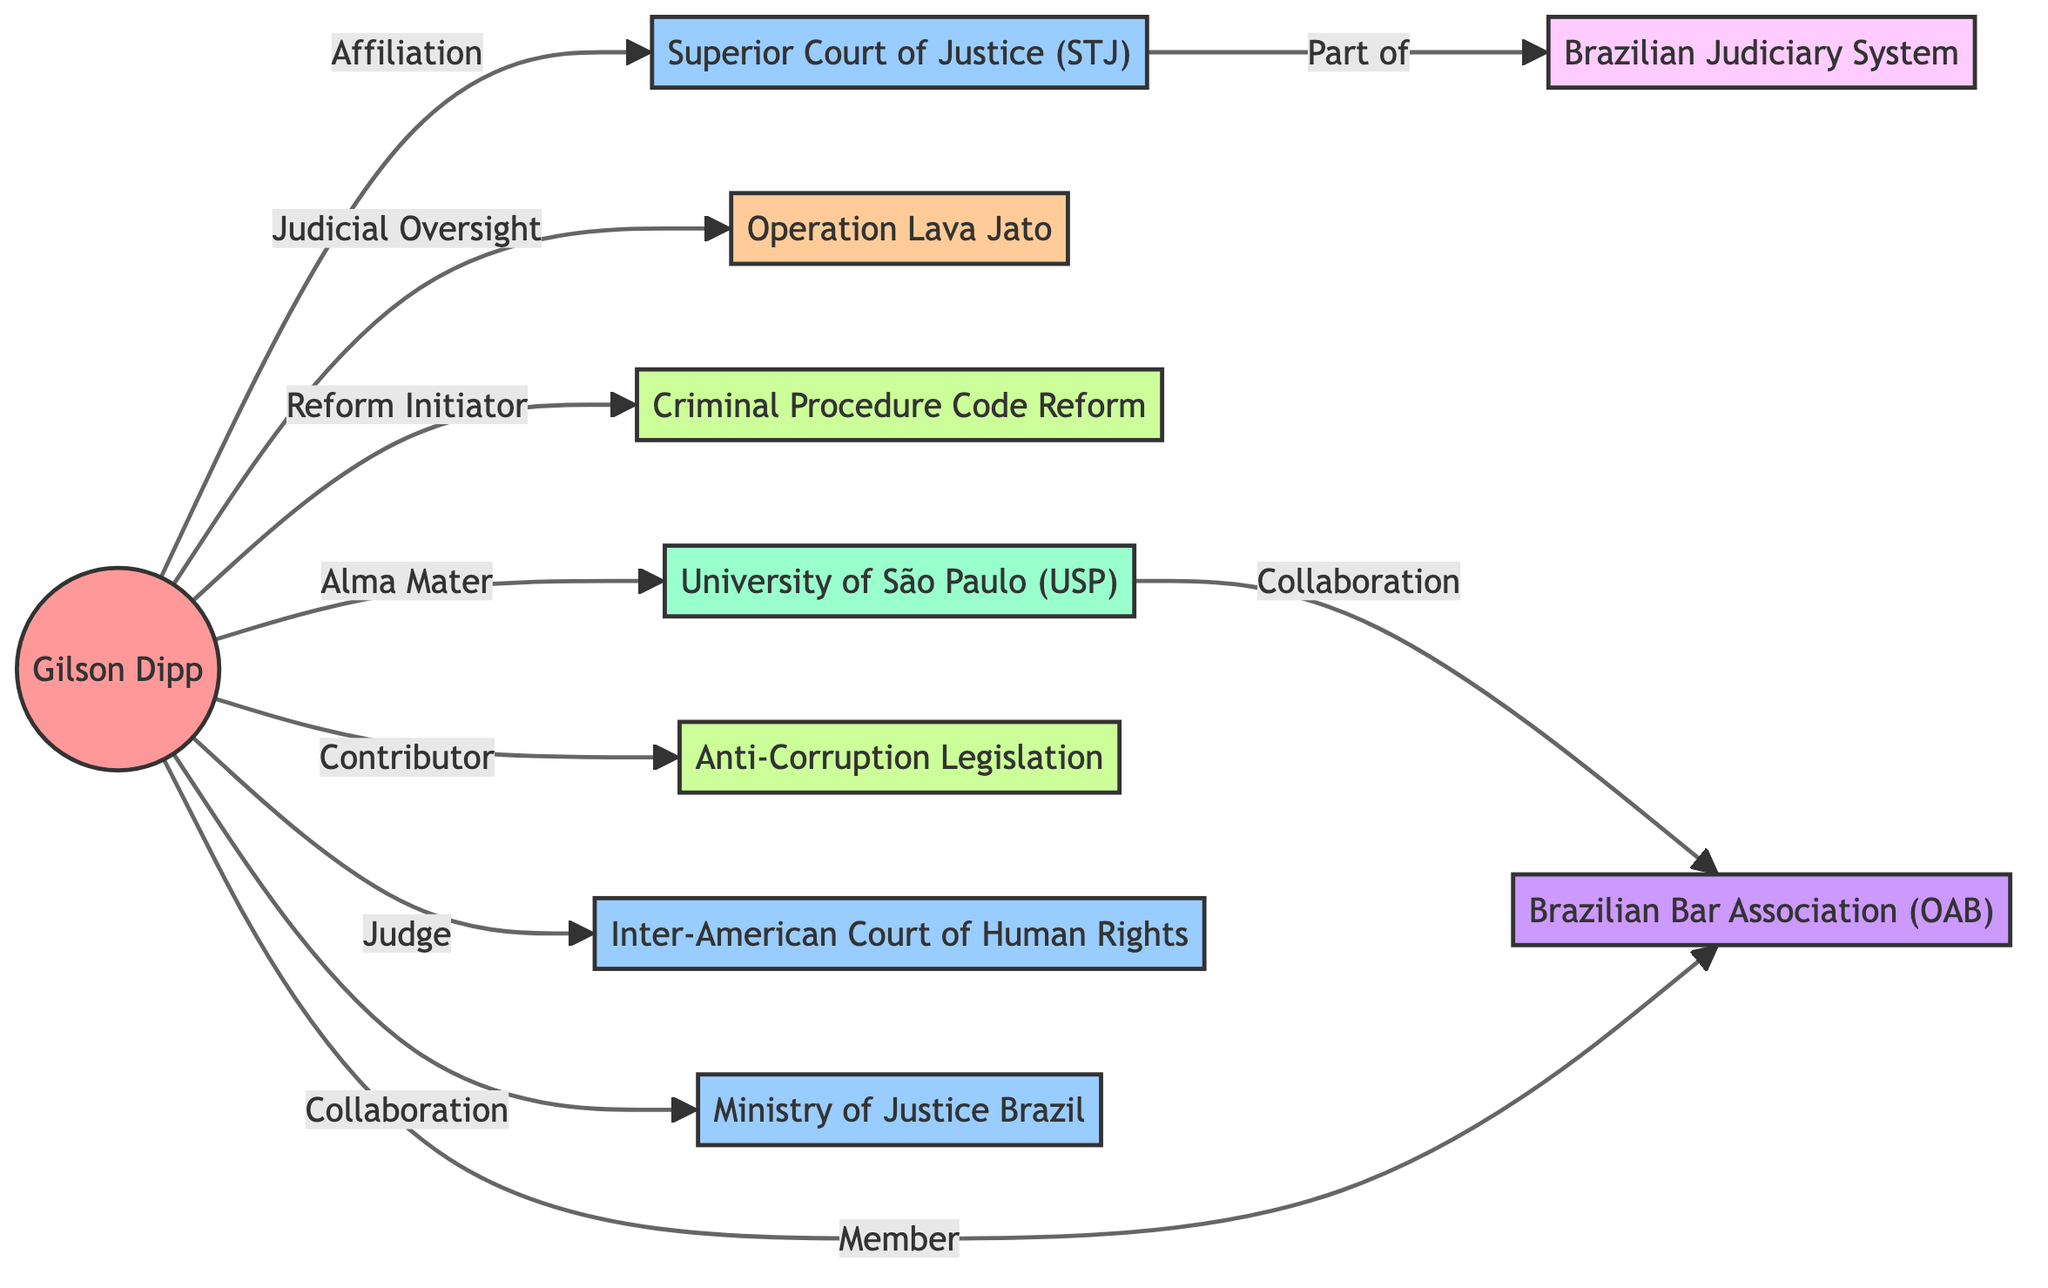What is the total number of nodes in the diagram? The diagram includes a list of nodes: Gilson Dipp, Superior Court of Justice (STJ), Operation Lava Jato, Criminal Procedure Code Reform, Brazilian Judiciary System, University of São Paulo (USP), Anti-Corruption Legislation, Inter-American Court of Human Rights, Brazilian Bar Association (OAB), and Ministry of Justice Brazil. Counting these gives a total of 10 nodes.
Answer: 10 Which institution is affiliated with Gilson Dipp? The edge labeled "Affiliation" connects Gilson Dipp to the Superior Court of Justice (STJ), indicating that STJ is the institution with which he is affiliated.
Answer: Superior Court of Justice (STJ) How many types of relationships are shown in the diagram? Examining the edges in the diagram reveals various relationship types: Professional Connection, Contribution, Affiliation, and Hierarchy. Counting these relationship types gives us 4 distinct types.
Answer: 4 Who initiated the Criminal Procedure Code Reform? The edge labeled "Reform Initiator" shows a direct connection from Gilson Dipp to Criminal Procedure Code Reform, indicating that he was the one who initiated this reform.
Answer: Gilson Dipp What type of professional connection is created by Gilson Dipp's involvement with the Inter-American Court of Human Rights? The label on the edge connecting Gilson Dipp and the Inter-American Court of Human Rights states "Judge", indicating the nature of the professional connection.
Answer: Judge Which academic institution is mentioned in the diagram? The diagram includes University of São Paulo (USP) as one of the nodes, clearly indicating it as the academic institution associated with Gilson Dipp.
Answer: University of São Paulo (USP) How is the Brazilian Bar Association (OAB) connected to Gilson Dipp? There are two edges linking Gilson Dipp to the Brazilian Bar Association (OAB): one labeled "Member" (indicating affiliation) and the other labeled "Collaboration" (indicating a professional connection).
Answer: Member and Collaboration Which case is related to Gilson Dipp's judicial oversight? The edge labeled "Judicial Oversight" directly connects Gilson Dipp to the case Operation Lava Jato, indicating the involvement of Gilson Dipp in this case.
Answer: Operation Lava Jato Which institution is part of the Brazilian Judiciary System? The label on the edge connecting Superior Court of Justice (STJ) to Brazilian Judiciary System states "Part of", indicating that the STJ is a part of the entire Brazilian Judiciary System.
Answer: Brazilian Judiciary System 